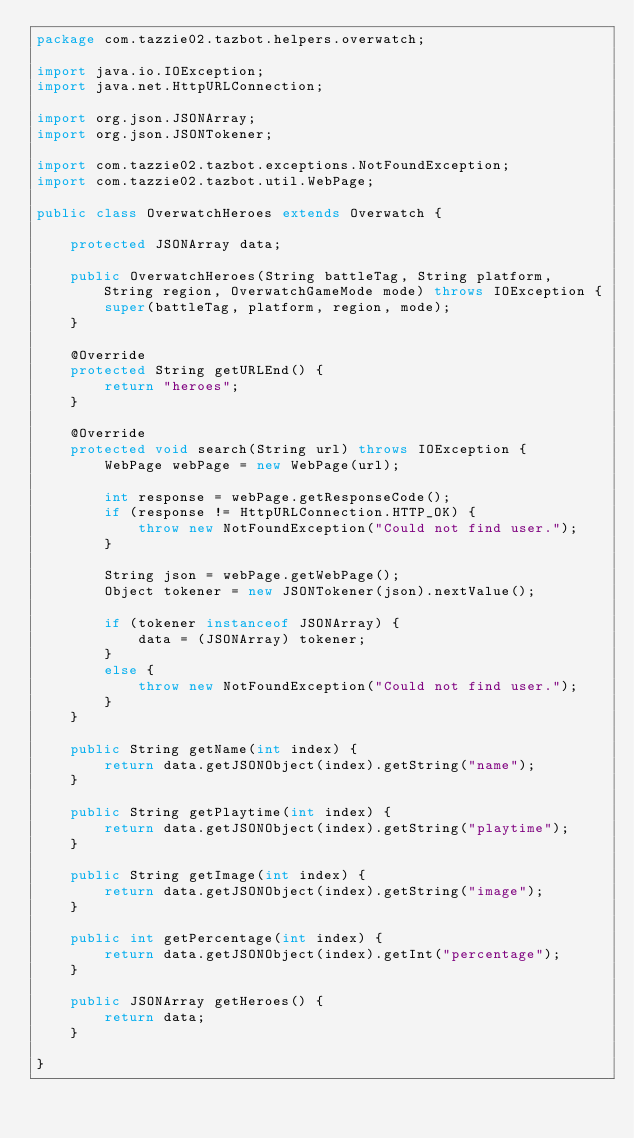<code> <loc_0><loc_0><loc_500><loc_500><_Java_>package com.tazzie02.tazbot.helpers.overwatch;

import java.io.IOException;
import java.net.HttpURLConnection;

import org.json.JSONArray;
import org.json.JSONTokener;

import com.tazzie02.tazbot.exceptions.NotFoundException;
import com.tazzie02.tazbot.util.WebPage;

public class OverwatchHeroes extends Overwatch {
	
	protected JSONArray data;

	public OverwatchHeroes(String battleTag, String platform, String region, OverwatchGameMode mode) throws IOException {
		super(battleTag, platform, region, mode);
	}

	@Override
	protected String getURLEnd() {
		return "heroes";
	}
	
	@Override
	protected void search(String url) throws IOException {
		WebPage webPage = new WebPage(url);
		
		int response = webPage.getResponseCode();
		if (response != HttpURLConnection.HTTP_OK) {
			throw new NotFoundException("Could not find user.");
		}
		
		String json = webPage.getWebPage();
		Object tokener = new JSONTokener(json).nextValue();
		
		if (tokener instanceof JSONArray) {
			data = (JSONArray) tokener;
		}
		else {
			throw new NotFoundException("Could not find user.");
		}
	}
	
	public String getName(int index) {
		return data.getJSONObject(index).getString("name");
	}
	
	public String getPlaytime(int index) {
		return data.getJSONObject(index).getString("playtime");
	}
	
	public String getImage(int index) {
		return data.getJSONObject(index).getString("image");
	}
	
	public int getPercentage(int index) {
		return data.getJSONObject(index).getInt("percentage");
	}
	
	public JSONArray getHeroes() {
		return data;
	}

}
</code> 